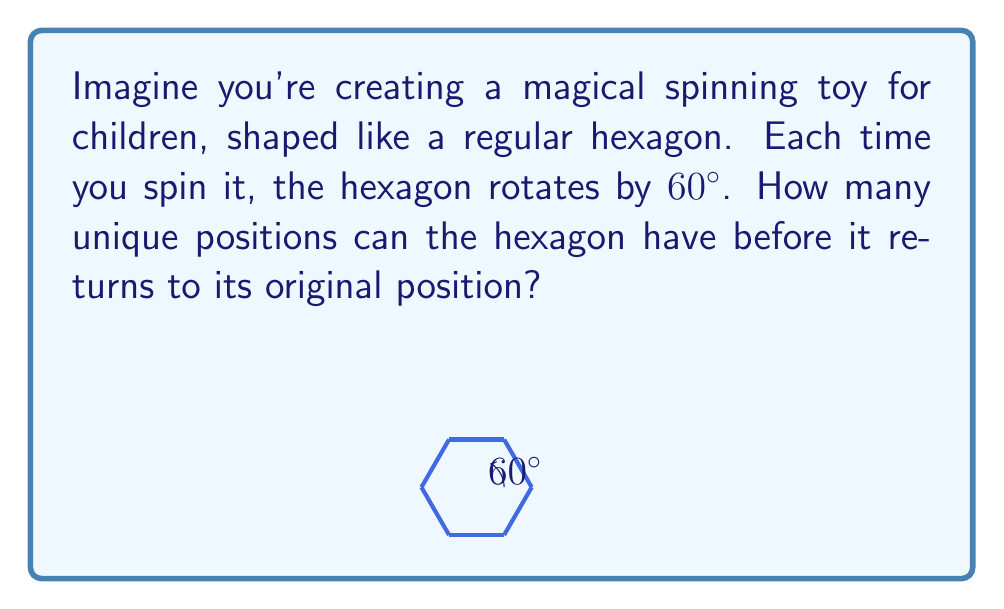Can you solve this math problem? Let's approach this step-by-step:

1) First, we need to understand what a cyclic group is in this context. It's a group generated by a single element, in this case, the rotation.

2) The order of a cyclic group is the number of unique elements in the group before it returns to the identity element (original position).

3) For a regular hexagon:
   - It has 6 sides
   - Each rotation is 60° (because $360° ÷ 6 = 60°$)

4) Let's list out the rotations:
   - 0° (original position)
   - 60°
   - 120°
   - 180°
   - 240°
   - 300°
   - 360° (back to original position)

5) We can see that after 6 rotations, we're back where we started.

6) Therefore, the cyclic group formed by these rotations has 6 unique elements.

7) In group theory terms, we would say that the order of this cyclic group is 6.

This concept can be generalized: for any regular polygon with $n$ sides, the order of the cyclic group formed by its rotations will be $n$.
Answer: 6 